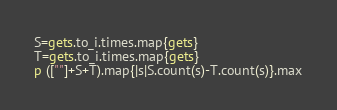<code> <loc_0><loc_0><loc_500><loc_500><_Ruby_>S=gets.to_i.times.map{gets}
T=gets.to_i.times.map{gets}
p ([""]+S+T).map{|s|S.count(s)-T.count(s)}.max</code> 